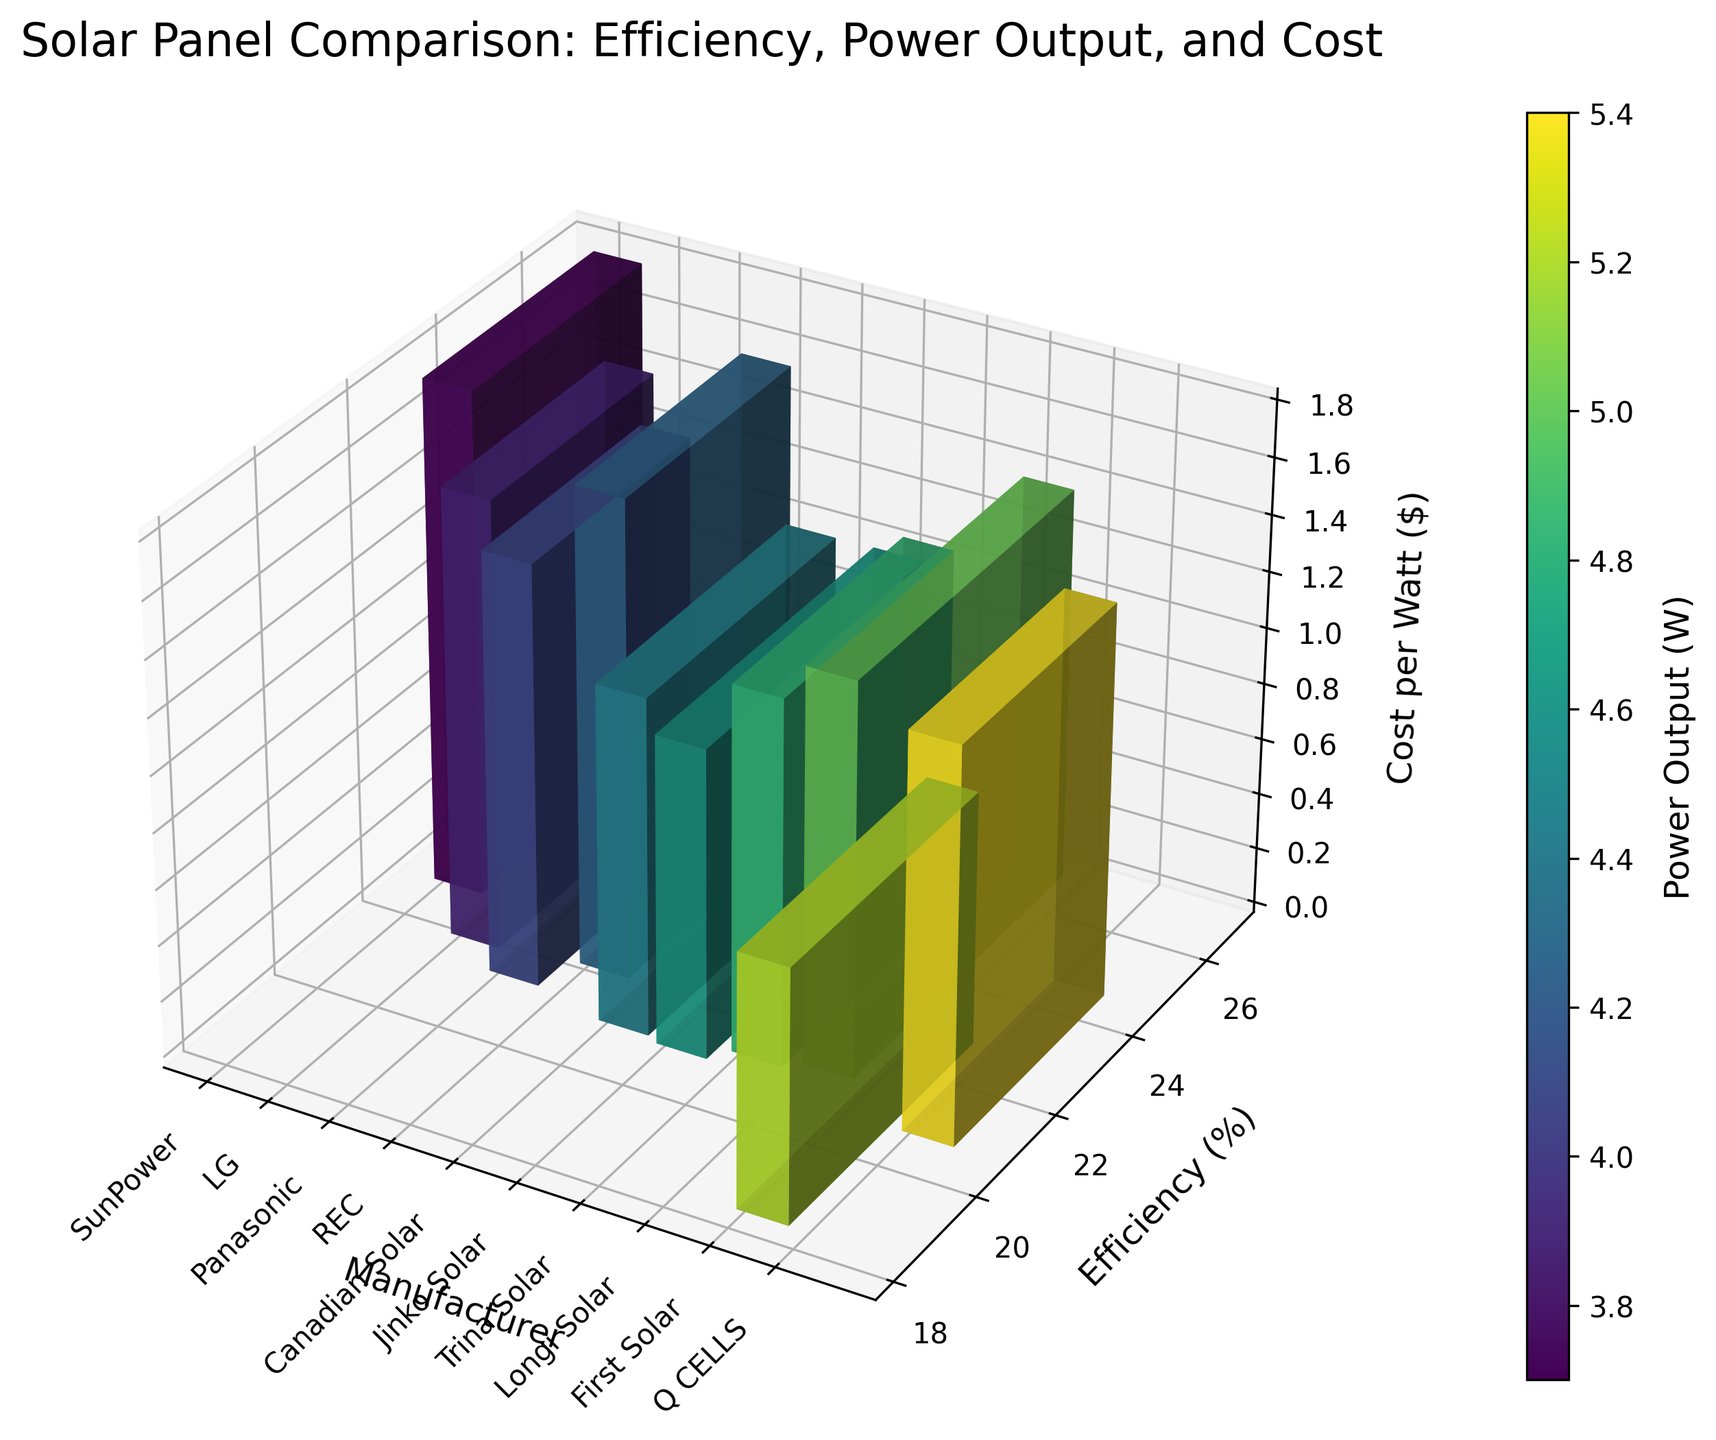What's the title of the figure? The title of the figure is usually displayed at the top. In this case, the title is clearly shown above the plot.
Answer: Solar Panel Comparison: Efficiency, Power Output, and Cost What does the x-axis represent? The x-axis represents the manufacturers of the solar panels. This can be seen from the labels such as SunPower, LG, Panasonic, etc., aligned along the x-axis.
Answer: Manufacturer Which solar panel manufacturer has the highest efficiency? From the y-axis representing efficiency (%) and the corresponding bar heights, the manufacturer with the highest bar is SunPower.
Answer: SunPower Between LG and REC, which one has a lower cost per watt on average? The z-axis represents the cost per watt ($), and the bar height indicates this metric. Comparing the heights of the bars for LG and REC, LG has a slightly lower bar.
Answer: LG What is the colorbar representing in this plot? The colorbar on the right side of the plot indicates the Power Output (W) with a gradient from the colormap.
Answer: Power Output (W) How does the efficiency of SunPower compare to Panasonic? By looking at the y-axis (Efficiency %) values, SunPower (22.7%) is higher than Panasonic (21.2%).
Answer: Higher Arrange the manufacturers in descending order of their power output. From the color gradient on the bars corresponding to each manufacturer, we compare the power outputs and arrange them: Longi Solar, Jinko Solar, Canadian Solar, First Solar, Trina Solar, SunPower, REC, LG, Q CELLS, Panasonic.
Answer: Longi Solar, Jinko Solar, Canadian Solar, First Solar, Trina Solar, SunPower, REC, LG, Q CELLS, Panasonic Which manufacturer has the lowest cost per watt but does not have the lowest efficiency? By comparing the heights of the bars on the z-axis for cost per watt and checking the y-axis for efficiency, Jinko Solar has the lowest cost per watt ($1.1) but its efficiency (20.8%) is not the lowest.
Answer: Jinko Solar What's the difference in power output between the manufacturers with the highest and lowest efficiency? SunPower has the highest efficiency (22.7%) with a power output of 400 W, and First Solar has the lowest efficiency (18.2%) with a power output of 450 W. The difference is 450 W - 400 W.
Answer: 50 W 